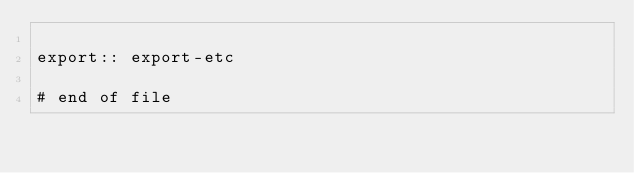<code> <loc_0><loc_0><loc_500><loc_500><_ObjectiveC_>
export:: export-etc

# end of file
</code> 